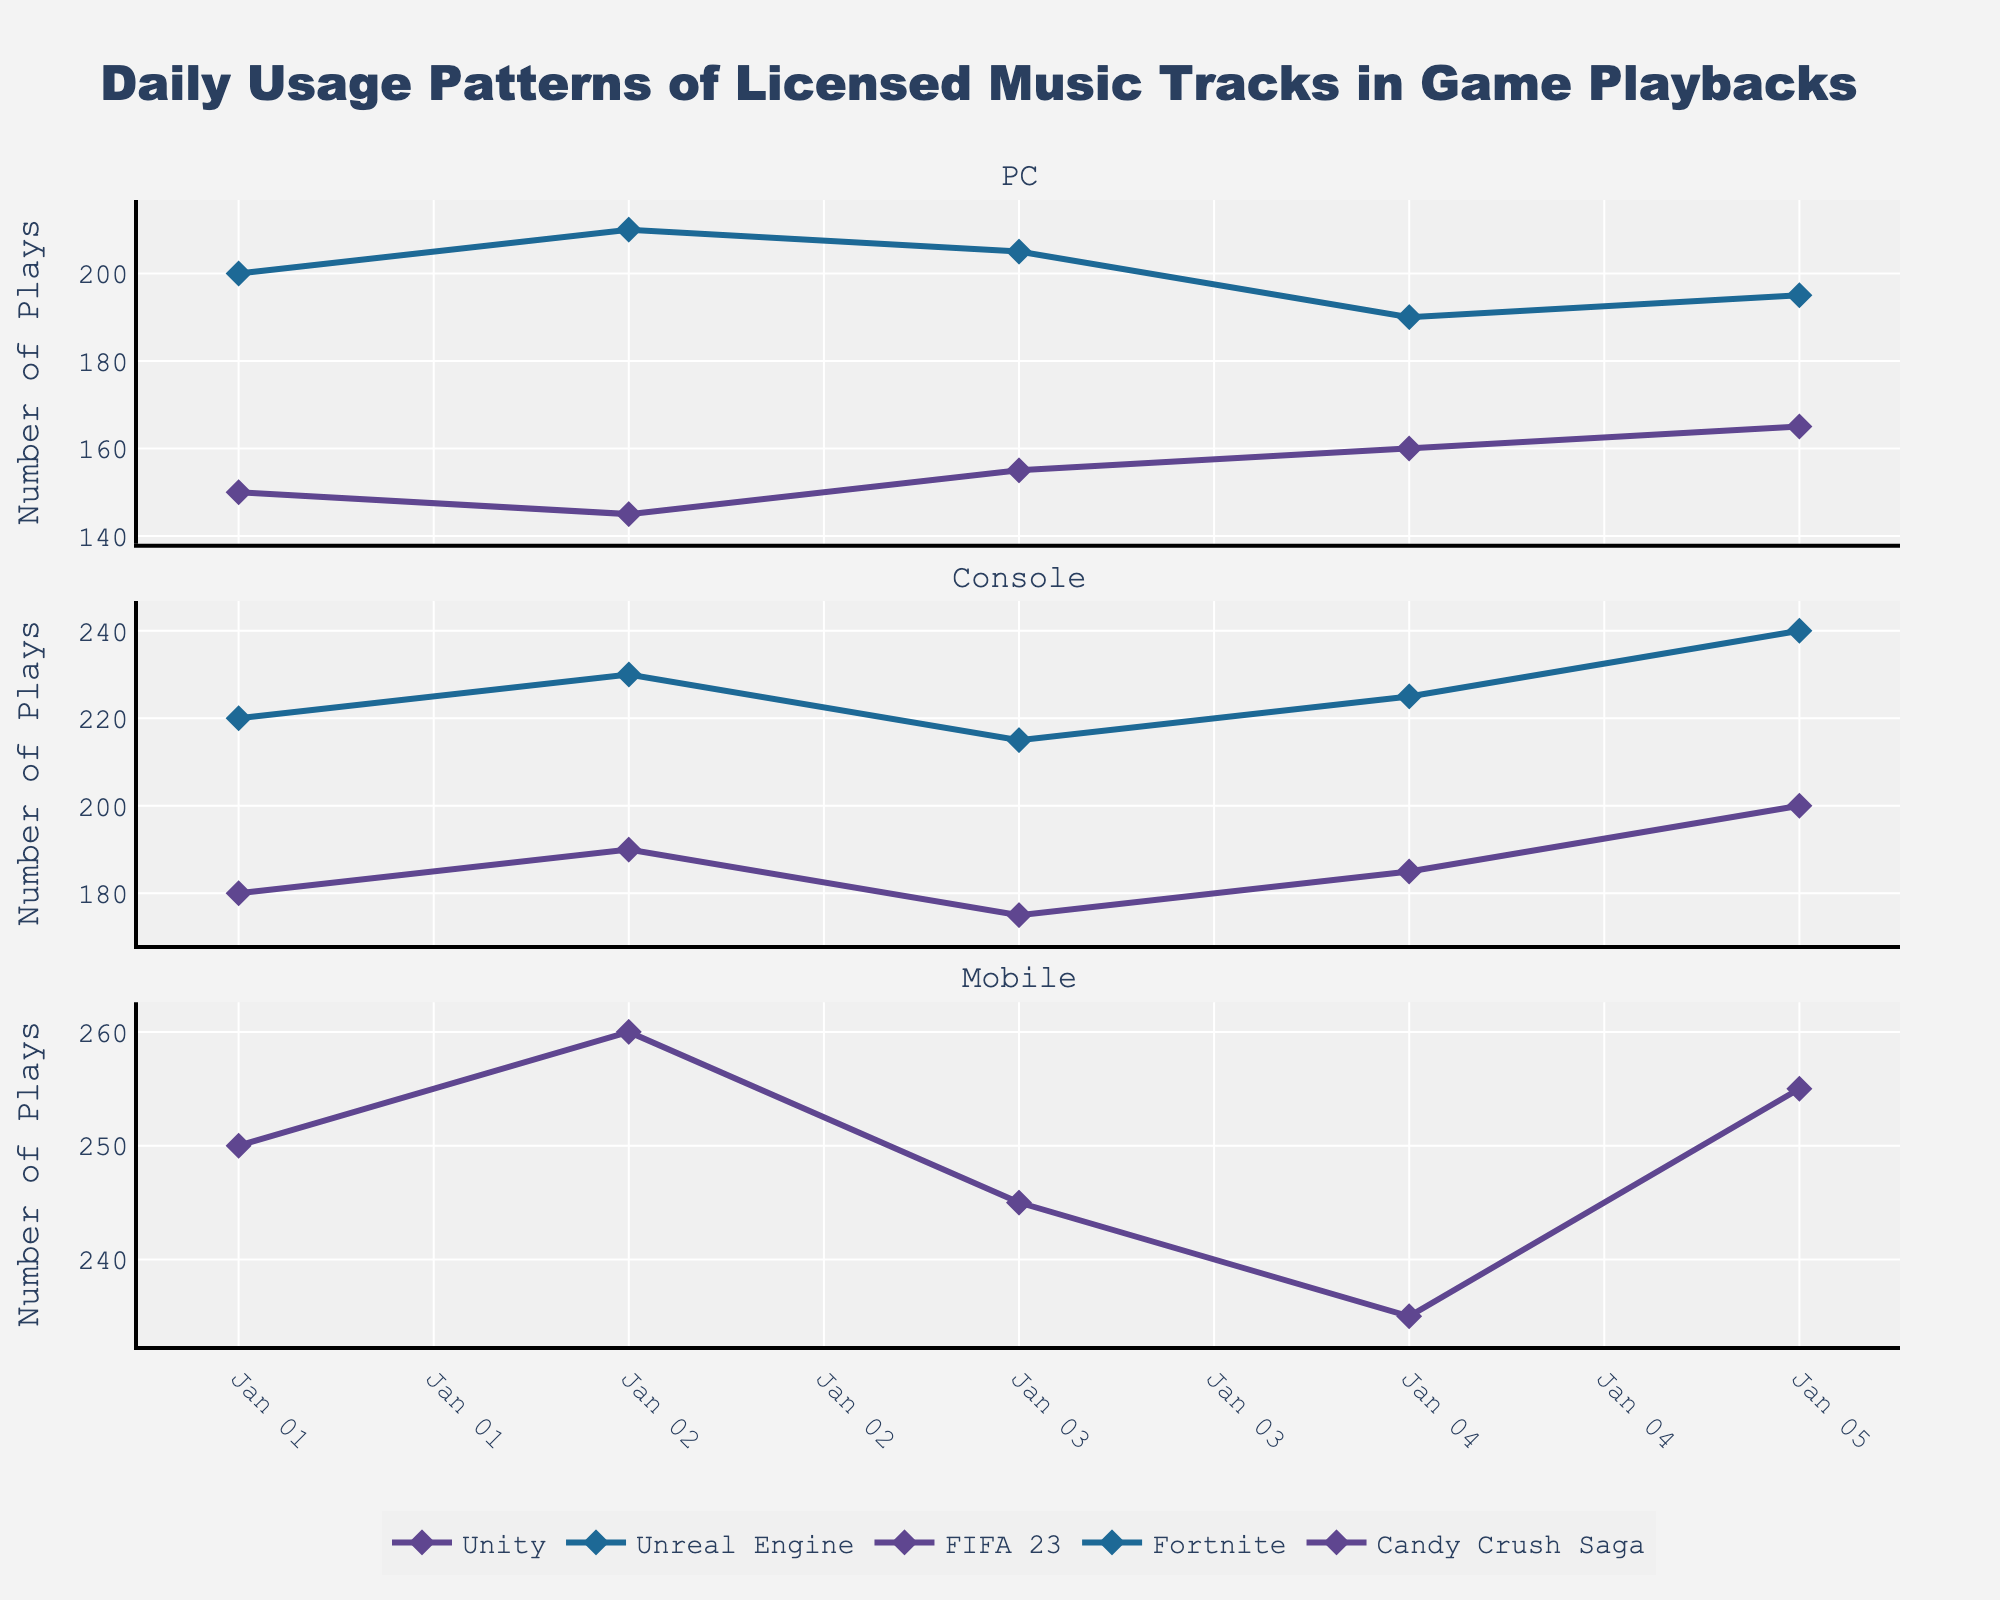What's the title of the figure? The title is typically placed at the top of the figure and is used to describe the main subject of the plot. Look for large, bold text at the top.
Answer: Daily Usage Patterns of Licensed Music Tracks in Game Playbacks Which platform had the highest number of plays on January 1, 2023? Look at the x-axis for January 1, 2023, and then compare the heights of the markers for each platform. The taller the marker, the higher the number of plays.
Answer: Mobile What was the overall trend for 'Unity' on the PC platform? Observe the line pattern for 'Unity' under the PC subplot. Follow the line's direction over the dates from left (earliest) to right (latest).
Answer: Increasing Compare the usage patterns of 'FIFA 23' and 'Fortnite' on the Console platform. Which track had more plays on January 3, 2023? Find the lines for 'FIFA 23' and 'Fortnite' within the Console subplot, then locate January 3, 2023, and compare the y-values.
Answer: Fortnite How many unique tracks are displayed for the PC platform? Look in the PC subplot (first one) and count the different lines or markers. Each unique color or marker represents a different track.
Answer: 2 What's the average plays per day for 'Unreal Engine' on the PC from January 1 to January 5, 2023? Sum the number of plays for 'Unreal Engine' each day from January 1 to January 5 and divide by the number of days (5).
Answer: 200 Between 'Candy Crush Saga' on Mobile and 'FIFA 23' on Console, which track showed a decreasing trend overall from January 1 to January 5, 2023? Examine the line patterns for 'Candy Crush Saga' in the Mobile subplot and 'FIFA 23' in the Console subplot. Identify which one generally decreases over the given dates.
Answer: Candy Crush Saga Which day reported the highest overall engagements across all platforms? Aggregate the total plays for each day across all tracks and platforms, then identify the day with the highest sum.
Answer: January 2, 2023 What is the marker shape used for plotting the data points in this figure? Observe the shape of the markers on the figure (look for diamond-like shapes on the lines).
Answer: Diamond Does the usage pattern for 'Fortnite' on Console reflect any consistent daily increase pattern from January 1 to January 5? Follow the line for 'Fortnite' in the Console subplot to see if it consistently increases over the specified dates.
Answer: Yes 